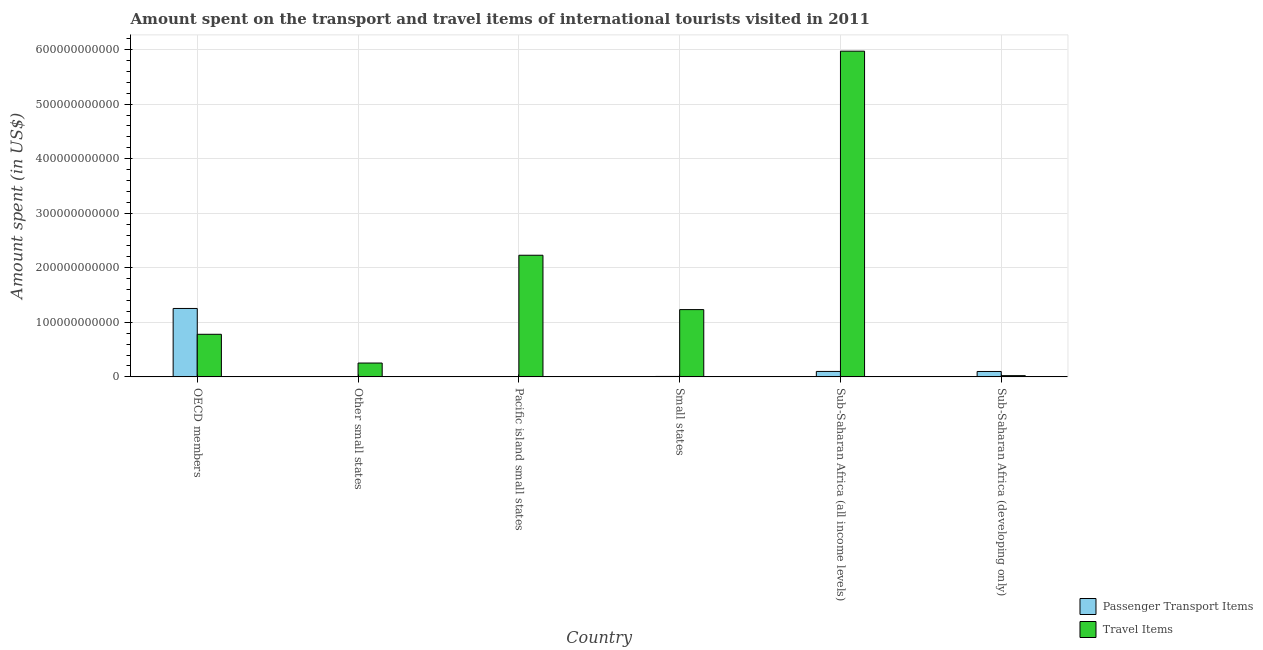How many different coloured bars are there?
Give a very brief answer. 2. Are the number of bars per tick equal to the number of legend labels?
Your response must be concise. Yes. How many bars are there on the 1st tick from the right?
Give a very brief answer. 2. What is the label of the 4th group of bars from the left?
Your answer should be compact. Small states. In how many cases, is the number of bars for a given country not equal to the number of legend labels?
Provide a short and direct response. 0. What is the amount spent in travel items in Sub-Saharan Africa (developing only)?
Your answer should be very brief. 2.24e+09. Across all countries, what is the maximum amount spent in travel items?
Offer a terse response. 5.97e+11. Across all countries, what is the minimum amount spent on passenger transport items?
Ensure brevity in your answer.  8.85e+07. In which country was the amount spent in travel items minimum?
Provide a succinct answer. Sub-Saharan Africa (developing only). What is the total amount spent in travel items in the graph?
Offer a very short reply. 1.05e+12. What is the difference between the amount spent in travel items in Small states and that in Sub-Saharan Africa (all income levels)?
Provide a short and direct response. -4.74e+11. What is the difference between the amount spent in travel items in Small states and the amount spent on passenger transport items in Other small states?
Your response must be concise. 1.23e+11. What is the average amount spent on passenger transport items per country?
Offer a very short reply. 2.44e+1. What is the difference between the amount spent on passenger transport items and amount spent in travel items in Pacific island small states?
Your response must be concise. -2.23e+11. In how many countries, is the amount spent in travel items greater than 200000000000 US$?
Offer a terse response. 2. What is the ratio of the amount spent in travel items in Small states to that in Sub-Saharan Africa (developing only)?
Offer a very short reply. 54.99. What is the difference between the highest and the second highest amount spent on passenger transport items?
Your answer should be very brief. 1.15e+11. What is the difference between the highest and the lowest amount spent in travel items?
Provide a succinct answer. 5.95e+11. Is the sum of the amount spent on passenger transport items in OECD members and Sub-Saharan Africa (developing only) greater than the maximum amount spent in travel items across all countries?
Your answer should be compact. No. What does the 2nd bar from the left in Sub-Saharan Africa (developing only) represents?
Offer a very short reply. Travel Items. What does the 1st bar from the right in Sub-Saharan Africa (developing only) represents?
Your answer should be very brief. Travel Items. How many bars are there?
Give a very brief answer. 12. How many countries are there in the graph?
Your answer should be compact. 6. What is the difference between two consecutive major ticks on the Y-axis?
Provide a short and direct response. 1.00e+11. Are the values on the major ticks of Y-axis written in scientific E-notation?
Offer a very short reply. No. Does the graph contain grids?
Keep it short and to the point. Yes. Where does the legend appear in the graph?
Give a very brief answer. Bottom right. How are the legend labels stacked?
Offer a terse response. Vertical. What is the title of the graph?
Make the answer very short. Amount spent on the transport and travel items of international tourists visited in 2011. Does "Female entrants" appear as one of the legend labels in the graph?
Keep it short and to the point. No. What is the label or title of the Y-axis?
Provide a short and direct response. Amount spent (in US$). What is the Amount spent (in US$) in Passenger Transport Items in OECD members?
Provide a succinct answer. 1.25e+11. What is the Amount spent (in US$) in Travel Items in OECD members?
Make the answer very short. 7.81e+1. What is the Amount spent (in US$) in Passenger Transport Items in Other small states?
Your answer should be very brief. 3.85e+08. What is the Amount spent (in US$) of Travel Items in Other small states?
Keep it short and to the point. 2.54e+1. What is the Amount spent (in US$) in Passenger Transport Items in Pacific island small states?
Keep it short and to the point. 8.85e+07. What is the Amount spent (in US$) in Travel Items in Pacific island small states?
Your answer should be very brief. 2.23e+11. What is the Amount spent (in US$) in Passenger Transport Items in Small states?
Ensure brevity in your answer.  7.84e+08. What is the Amount spent (in US$) of Travel Items in Small states?
Offer a terse response. 1.23e+11. What is the Amount spent (in US$) of Passenger Transport Items in Sub-Saharan Africa (all income levels)?
Your answer should be very brief. 9.97e+09. What is the Amount spent (in US$) of Travel Items in Sub-Saharan Africa (all income levels)?
Your response must be concise. 5.97e+11. What is the Amount spent (in US$) in Passenger Transport Items in Sub-Saharan Africa (developing only)?
Keep it short and to the point. 9.88e+09. What is the Amount spent (in US$) in Travel Items in Sub-Saharan Africa (developing only)?
Make the answer very short. 2.24e+09. Across all countries, what is the maximum Amount spent (in US$) of Passenger Transport Items?
Ensure brevity in your answer.  1.25e+11. Across all countries, what is the maximum Amount spent (in US$) of Travel Items?
Provide a short and direct response. 5.97e+11. Across all countries, what is the minimum Amount spent (in US$) in Passenger Transport Items?
Give a very brief answer. 8.85e+07. Across all countries, what is the minimum Amount spent (in US$) in Travel Items?
Give a very brief answer. 2.24e+09. What is the total Amount spent (in US$) of Passenger Transport Items in the graph?
Keep it short and to the point. 1.47e+11. What is the total Amount spent (in US$) of Travel Items in the graph?
Ensure brevity in your answer.  1.05e+12. What is the difference between the Amount spent (in US$) of Passenger Transport Items in OECD members and that in Other small states?
Provide a succinct answer. 1.25e+11. What is the difference between the Amount spent (in US$) in Travel Items in OECD members and that in Other small states?
Your answer should be compact. 5.27e+1. What is the difference between the Amount spent (in US$) in Passenger Transport Items in OECD members and that in Pacific island small states?
Keep it short and to the point. 1.25e+11. What is the difference between the Amount spent (in US$) of Travel Items in OECD members and that in Pacific island small states?
Ensure brevity in your answer.  -1.45e+11. What is the difference between the Amount spent (in US$) in Passenger Transport Items in OECD members and that in Small states?
Your answer should be compact. 1.25e+11. What is the difference between the Amount spent (in US$) of Travel Items in OECD members and that in Small states?
Your answer should be compact. -4.52e+1. What is the difference between the Amount spent (in US$) of Passenger Transport Items in OECD members and that in Sub-Saharan Africa (all income levels)?
Your answer should be compact. 1.15e+11. What is the difference between the Amount spent (in US$) in Travel Items in OECD members and that in Sub-Saharan Africa (all income levels)?
Your answer should be compact. -5.19e+11. What is the difference between the Amount spent (in US$) in Passenger Transport Items in OECD members and that in Sub-Saharan Africa (developing only)?
Offer a terse response. 1.16e+11. What is the difference between the Amount spent (in US$) of Travel Items in OECD members and that in Sub-Saharan Africa (developing only)?
Provide a short and direct response. 7.58e+1. What is the difference between the Amount spent (in US$) of Passenger Transport Items in Other small states and that in Pacific island small states?
Offer a very short reply. 2.96e+08. What is the difference between the Amount spent (in US$) of Travel Items in Other small states and that in Pacific island small states?
Your answer should be very brief. -1.98e+11. What is the difference between the Amount spent (in US$) of Passenger Transport Items in Other small states and that in Small states?
Give a very brief answer. -3.99e+08. What is the difference between the Amount spent (in US$) in Travel Items in Other small states and that in Small states?
Your response must be concise. -9.79e+1. What is the difference between the Amount spent (in US$) in Passenger Transport Items in Other small states and that in Sub-Saharan Africa (all income levels)?
Your response must be concise. -9.59e+09. What is the difference between the Amount spent (in US$) of Travel Items in Other small states and that in Sub-Saharan Africa (all income levels)?
Give a very brief answer. -5.72e+11. What is the difference between the Amount spent (in US$) of Passenger Transport Items in Other small states and that in Sub-Saharan Africa (developing only)?
Your answer should be compact. -9.49e+09. What is the difference between the Amount spent (in US$) in Travel Items in Other small states and that in Sub-Saharan Africa (developing only)?
Your answer should be very brief. 2.31e+1. What is the difference between the Amount spent (in US$) in Passenger Transport Items in Pacific island small states and that in Small states?
Provide a succinct answer. -6.95e+08. What is the difference between the Amount spent (in US$) in Travel Items in Pacific island small states and that in Small states?
Ensure brevity in your answer.  9.96e+1. What is the difference between the Amount spent (in US$) of Passenger Transport Items in Pacific island small states and that in Sub-Saharan Africa (all income levels)?
Ensure brevity in your answer.  -9.88e+09. What is the difference between the Amount spent (in US$) in Travel Items in Pacific island small states and that in Sub-Saharan Africa (all income levels)?
Your answer should be compact. -3.74e+11. What is the difference between the Amount spent (in US$) in Passenger Transport Items in Pacific island small states and that in Sub-Saharan Africa (developing only)?
Ensure brevity in your answer.  -9.79e+09. What is the difference between the Amount spent (in US$) in Travel Items in Pacific island small states and that in Sub-Saharan Africa (developing only)?
Offer a terse response. 2.21e+11. What is the difference between the Amount spent (in US$) of Passenger Transport Items in Small states and that in Sub-Saharan Africa (all income levels)?
Give a very brief answer. -9.19e+09. What is the difference between the Amount spent (in US$) in Travel Items in Small states and that in Sub-Saharan Africa (all income levels)?
Give a very brief answer. -4.74e+11. What is the difference between the Amount spent (in US$) of Passenger Transport Items in Small states and that in Sub-Saharan Africa (developing only)?
Ensure brevity in your answer.  -9.09e+09. What is the difference between the Amount spent (in US$) in Travel Items in Small states and that in Sub-Saharan Africa (developing only)?
Make the answer very short. 1.21e+11. What is the difference between the Amount spent (in US$) of Passenger Transport Items in Sub-Saharan Africa (all income levels) and that in Sub-Saharan Africa (developing only)?
Offer a very short reply. 9.62e+07. What is the difference between the Amount spent (in US$) of Travel Items in Sub-Saharan Africa (all income levels) and that in Sub-Saharan Africa (developing only)?
Keep it short and to the point. 5.95e+11. What is the difference between the Amount spent (in US$) in Passenger Transport Items in OECD members and the Amount spent (in US$) in Travel Items in Other small states?
Keep it short and to the point. 1.00e+11. What is the difference between the Amount spent (in US$) in Passenger Transport Items in OECD members and the Amount spent (in US$) in Travel Items in Pacific island small states?
Offer a very short reply. -9.75e+1. What is the difference between the Amount spent (in US$) of Passenger Transport Items in OECD members and the Amount spent (in US$) of Travel Items in Small states?
Your answer should be very brief. 2.10e+09. What is the difference between the Amount spent (in US$) of Passenger Transport Items in OECD members and the Amount spent (in US$) of Travel Items in Sub-Saharan Africa (all income levels)?
Your answer should be compact. -4.72e+11. What is the difference between the Amount spent (in US$) of Passenger Transport Items in OECD members and the Amount spent (in US$) of Travel Items in Sub-Saharan Africa (developing only)?
Provide a short and direct response. 1.23e+11. What is the difference between the Amount spent (in US$) in Passenger Transport Items in Other small states and the Amount spent (in US$) in Travel Items in Pacific island small states?
Make the answer very short. -2.23e+11. What is the difference between the Amount spent (in US$) in Passenger Transport Items in Other small states and the Amount spent (in US$) in Travel Items in Small states?
Offer a terse response. -1.23e+11. What is the difference between the Amount spent (in US$) of Passenger Transport Items in Other small states and the Amount spent (in US$) of Travel Items in Sub-Saharan Africa (all income levels)?
Provide a short and direct response. -5.97e+11. What is the difference between the Amount spent (in US$) in Passenger Transport Items in Other small states and the Amount spent (in US$) in Travel Items in Sub-Saharan Africa (developing only)?
Your answer should be compact. -1.86e+09. What is the difference between the Amount spent (in US$) in Passenger Transport Items in Pacific island small states and the Amount spent (in US$) in Travel Items in Small states?
Give a very brief answer. -1.23e+11. What is the difference between the Amount spent (in US$) of Passenger Transport Items in Pacific island small states and the Amount spent (in US$) of Travel Items in Sub-Saharan Africa (all income levels)?
Give a very brief answer. -5.97e+11. What is the difference between the Amount spent (in US$) in Passenger Transport Items in Pacific island small states and the Amount spent (in US$) in Travel Items in Sub-Saharan Africa (developing only)?
Provide a short and direct response. -2.15e+09. What is the difference between the Amount spent (in US$) of Passenger Transport Items in Small states and the Amount spent (in US$) of Travel Items in Sub-Saharan Africa (all income levels)?
Your answer should be compact. -5.96e+11. What is the difference between the Amount spent (in US$) in Passenger Transport Items in Small states and the Amount spent (in US$) in Travel Items in Sub-Saharan Africa (developing only)?
Offer a terse response. -1.46e+09. What is the difference between the Amount spent (in US$) of Passenger Transport Items in Sub-Saharan Africa (all income levels) and the Amount spent (in US$) of Travel Items in Sub-Saharan Africa (developing only)?
Offer a very short reply. 7.73e+09. What is the average Amount spent (in US$) in Passenger Transport Items per country?
Provide a succinct answer. 2.44e+1. What is the average Amount spent (in US$) of Travel Items per country?
Provide a short and direct response. 1.75e+11. What is the difference between the Amount spent (in US$) in Passenger Transport Items and Amount spent (in US$) in Travel Items in OECD members?
Make the answer very short. 4.73e+1. What is the difference between the Amount spent (in US$) of Passenger Transport Items and Amount spent (in US$) of Travel Items in Other small states?
Your answer should be very brief. -2.50e+1. What is the difference between the Amount spent (in US$) in Passenger Transport Items and Amount spent (in US$) in Travel Items in Pacific island small states?
Make the answer very short. -2.23e+11. What is the difference between the Amount spent (in US$) of Passenger Transport Items and Amount spent (in US$) of Travel Items in Small states?
Keep it short and to the point. -1.23e+11. What is the difference between the Amount spent (in US$) in Passenger Transport Items and Amount spent (in US$) in Travel Items in Sub-Saharan Africa (all income levels)?
Make the answer very short. -5.87e+11. What is the difference between the Amount spent (in US$) in Passenger Transport Items and Amount spent (in US$) in Travel Items in Sub-Saharan Africa (developing only)?
Offer a very short reply. 7.63e+09. What is the ratio of the Amount spent (in US$) in Passenger Transport Items in OECD members to that in Other small states?
Give a very brief answer. 325.9. What is the ratio of the Amount spent (in US$) of Travel Items in OECD members to that in Other small states?
Provide a succinct answer. 3.08. What is the ratio of the Amount spent (in US$) in Passenger Transport Items in OECD members to that in Pacific island small states?
Provide a succinct answer. 1416.17. What is the ratio of the Amount spent (in US$) of Travel Items in OECD members to that in Pacific island small states?
Make the answer very short. 0.35. What is the ratio of the Amount spent (in US$) of Passenger Transport Items in OECD members to that in Small states?
Provide a succinct answer. 160.02. What is the ratio of the Amount spent (in US$) of Travel Items in OECD members to that in Small states?
Offer a terse response. 0.63. What is the ratio of the Amount spent (in US$) of Passenger Transport Items in OECD members to that in Sub-Saharan Africa (all income levels)?
Provide a succinct answer. 12.57. What is the ratio of the Amount spent (in US$) of Travel Items in OECD members to that in Sub-Saharan Africa (all income levels)?
Give a very brief answer. 0.13. What is the ratio of the Amount spent (in US$) in Passenger Transport Items in OECD members to that in Sub-Saharan Africa (developing only)?
Provide a succinct answer. 12.7. What is the ratio of the Amount spent (in US$) of Travel Items in OECD members to that in Sub-Saharan Africa (developing only)?
Ensure brevity in your answer.  34.82. What is the ratio of the Amount spent (in US$) in Passenger Transport Items in Other small states to that in Pacific island small states?
Make the answer very short. 4.35. What is the ratio of the Amount spent (in US$) of Travel Items in Other small states to that in Pacific island small states?
Keep it short and to the point. 0.11. What is the ratio of the Amount spent (in US$) of Passenger Transport Items in Other small states to that in Small states?
Make the answer very short. 0.49. What is the ratio of the Amount spent (in US$) of Travel Items in Other small states to that in Small states?
Keep it short and to the point. 0.21. What is the ratio of the Amount spent (in US$) in Passenger Transport Items in Other small states to that in Sub-Saharan Africa (all income levels)?
Keep it short and to the point. 0.04. What is the ratio of the Amount spent (in US$) of Travel Items in Other small states to that in Sub-Saharan Africa (all income levels)?
Offer a terse response. 0.04. What is the ratio of the Amount spent (in US$) of Passenger Transport Items in Other small states to that in Sub-Saharan Africa (developing only)?
Offer a terse response. 0.04. What is the ratio of the Amount spent (in US$) in Travel Items in Other small states to that in Sub-Saharan Africa (developing only)?
Offer a terse response. 11.31. What is the ratio of the Amount spent (in US$) of Passenger Transport Items in Pacific island small states to that in Small states?
Keep it short and to the point. 0.11. What is the ratio of the Amount spent (in US$) of Travel Items in Pacific island small states to that in Small states?
Ensure brevity in your answer.  1.81. What is the ratio of the Amount spent (in US$) of Passenger Transport Items in Pacific island small states to that in Sub-Saharan Africa (all income levels)?
Your response must be concise. 0.01. What is the ratio of the Amount spent (in US$) in Travel Items in Pacific island small states to that in Sub-Saharan Africa (all income levels)?
Provide a succinct answer. 0.37. What is the ratio of the Amount spent (in US$) in Passenger Transport Items in Pacific island small states to that in Sub-Saharan Africa (developing only)?
Offer a very short reply. 0.01. What is the ratio of the Amount spent (in US$) in Travel Items in Pacific island small states to that in Sub-Saharan Africa (developing only)?
Make the answer very short. 99.42. What is the ratio of the Amount spent (in US$) in Passenger Transport Items in Small states to that in Sub-Saharan Africa (all income levels)?
Give a very brief answer. 0.08. What is the ratio of the Amount spent (in US$) in Travel Items in Small states to that in Sub-Saharan Africa (all income levels)?
Make the answer very short. 0.21. What is the ratio of the Amount spent (in US$) in Passenger Transport Items in Small states to that in Sub-Saharan Africa (developing only)?
Give a very brief answer. 0.08. What is the ratio of the Amount spent (in US$) of Travel Items in Small states to that in Sub-Saharan Africa (developing only)?
Keep it short and to the point. 54.99. What is the ratio of the Amount spent (in US$) of Passenger Transport Items in Sub-Saharan Africa (all income levels) to that in Sub-Saharan Africa (developing only)?
Your answer should be compact. 1.01. What is the ratio of the Amount spent (in US$) of Travel Items in Sub-Saharan Africa (all income levels) to that in Sub-Saharan Africa (developing only)?
Provide a short and direct response. 266.26. What is the difference between the highest and the second highest Amount spent (in US$) in Passenger Transport Items?
Your response must be concise. 1.15e+11. What is the difference between the highest and the second highest Amount spent (in US$) in Travel Items?
Give a very brief answer. 3.74e+11. What is the difference between the highest and the lowest Amount spent (in US$) in Passenger Transport Items?
Keep it short and to the point. 1.25e+11. What is the difference between the highest and the lowest Amount spent (in US$) of Travel Items?
Make the answer very short. 5.95e+11. 